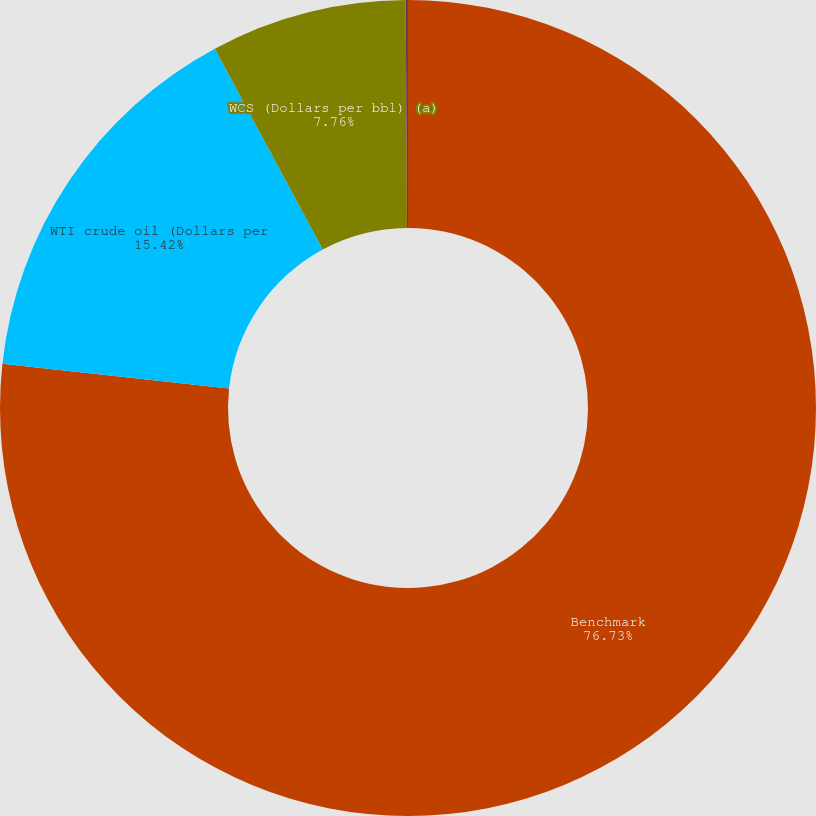Convert chart to OTSL. <chart><loc_0><loc_0><loc_500><loc_500><pie_chart><fcel>Benchmark<fcel>WTI crude oil (Dollars per<fcel>WCS (Dollars per bbl) (a)<fcel>AECO natural gas sales index<nl><fcel>76.73%<fcel>15.42%<fcel>7.76%<fcel>0.09%<nl></chart> 